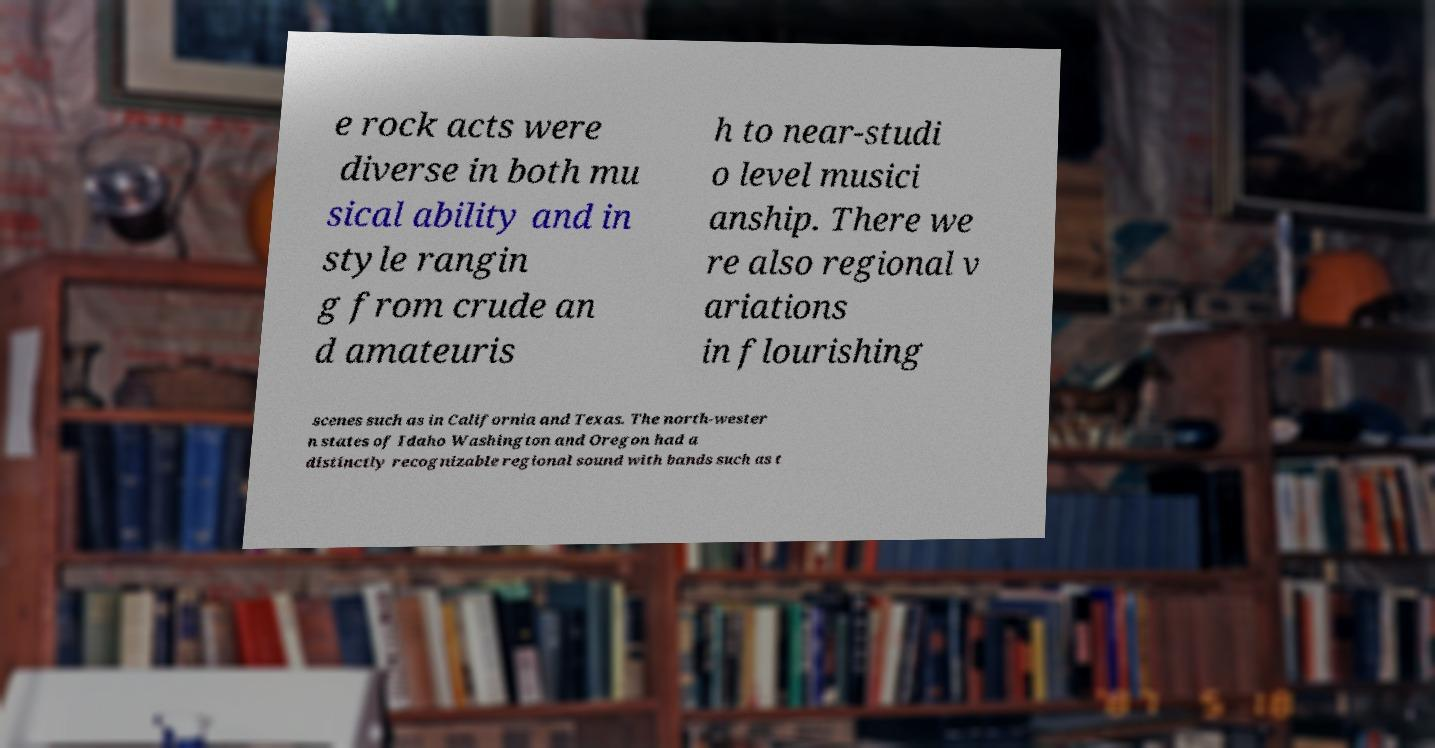Please read and relay the text visible in this image. What does it say? e rock acts were diverse in both mu sical ability and in style rangin g from crude an d amateuris h to near-studi o level musici anship. There we re also regional v ariations in flourishing scenes such as in California and Texas. The north-wester n states of Idaho Washington and Oregon had a distinctly recognizable regional sound with bands such as t 